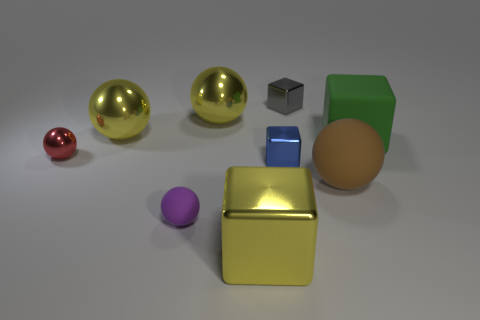Subtract all small gray metal blocks. How many blocks are left? 3 Subtract all yellow cubes. How many cubes are left? 3 Subtract 1 cubes. How many cubes are left? 3 Add 1 small gray blocks. How many objects exist? 10 Subtract all cubes. How many objects are left? 5 Subtract all red cylinders. How many green blocks are left? 1 Add 6 big yellow spheres. How many big yellow spheres exist? 8 Subtract 0 gray balls. How many objects are left? 9 Subtract all red cubes. Subtract all red balls. How many cubes are left? 4 Subtract all big gray cylinders. Subtract all small gray blocks. How many objects are left? 8 